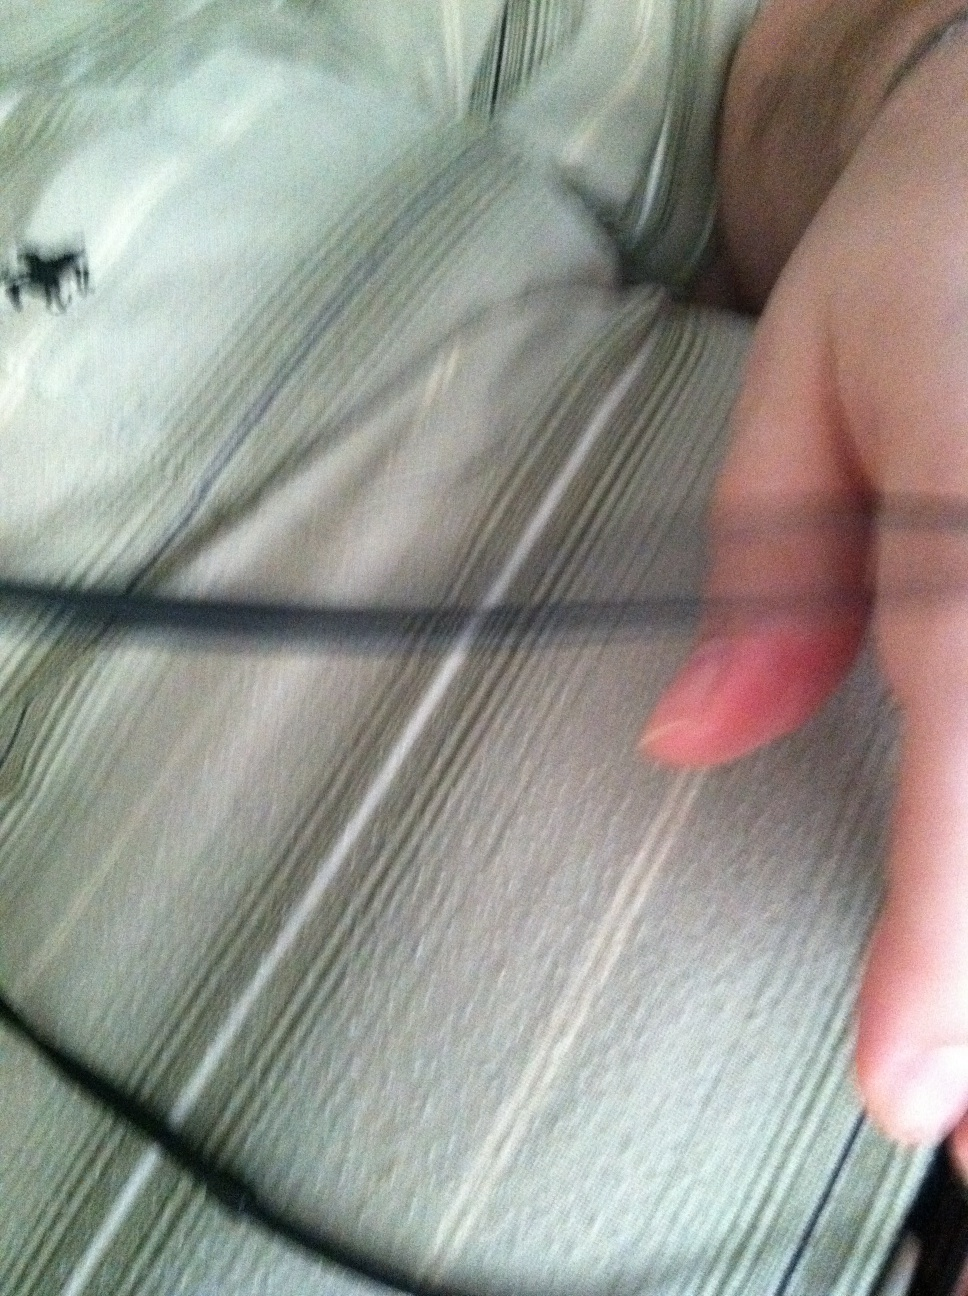What color is my shirt? Your shirt is predominantly grey with stripes, giving it a sophisticated and casual look. 